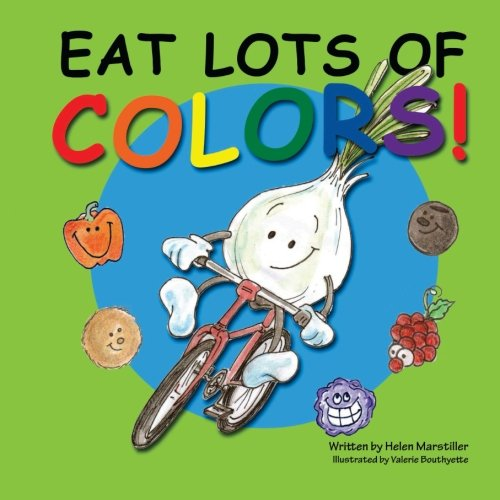What is the title of this book? The title of this educational and vibrant book designed for children is 'Eat Lots of Colors: A Colorful Look at Healthy Nutrition for Children'. It invites young readers to learn about the benefits of eating various colored fruits and vegetables. 